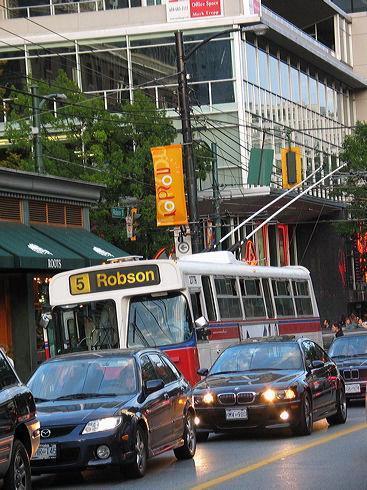How many cars are in the picture?
Give a very brief answer. 4. 